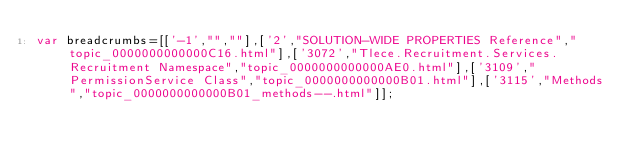<code> <loc_0><loc_0><loc_500><loc_500><_JavaScript_>var breadcrumbs=[['-1',"",""],['2',"SOLUTION-WIDE PROPERTIES Reference","topic_0000000000000C16.html"],['3072',"Tlece.Recruitment.Services.Recruitment Namespace","topic_0000000000000AE0.html"],['3109',"PermissionService Class","topic_0000000000000B01.html"],['3115',"Methods","topic_0000000000000B01_methods--.html"]];</code> 